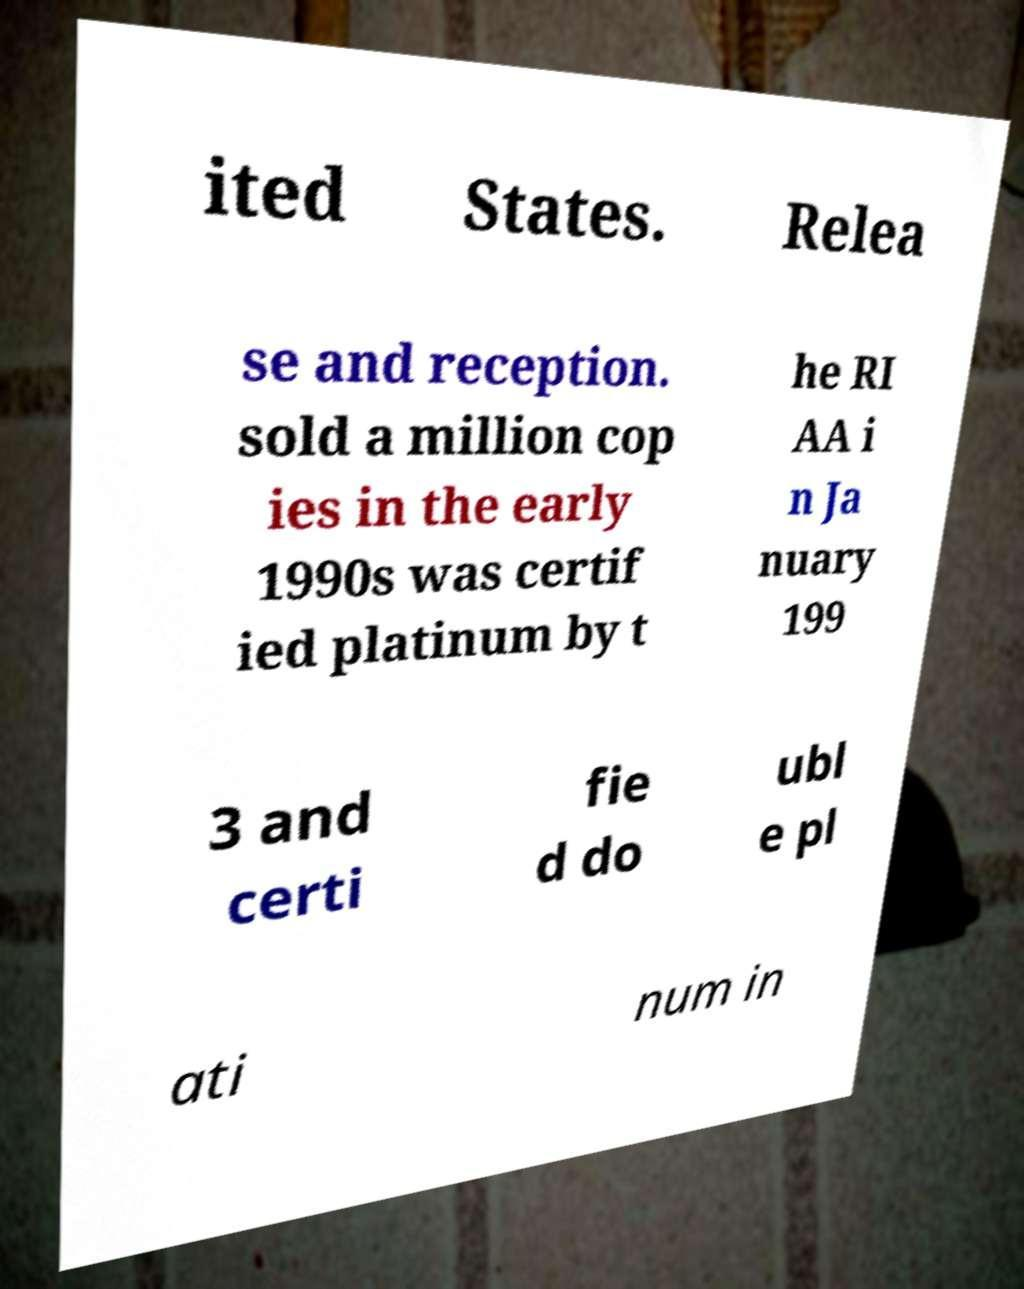Could you extract and type out the text from this image? ited States. Relea se and reception. sold a million cop ies in the early 1990s was certif ied platinum by t he RI AA i n Ja nuary 199 3 and certi fie d do ubl e pl ati num in 